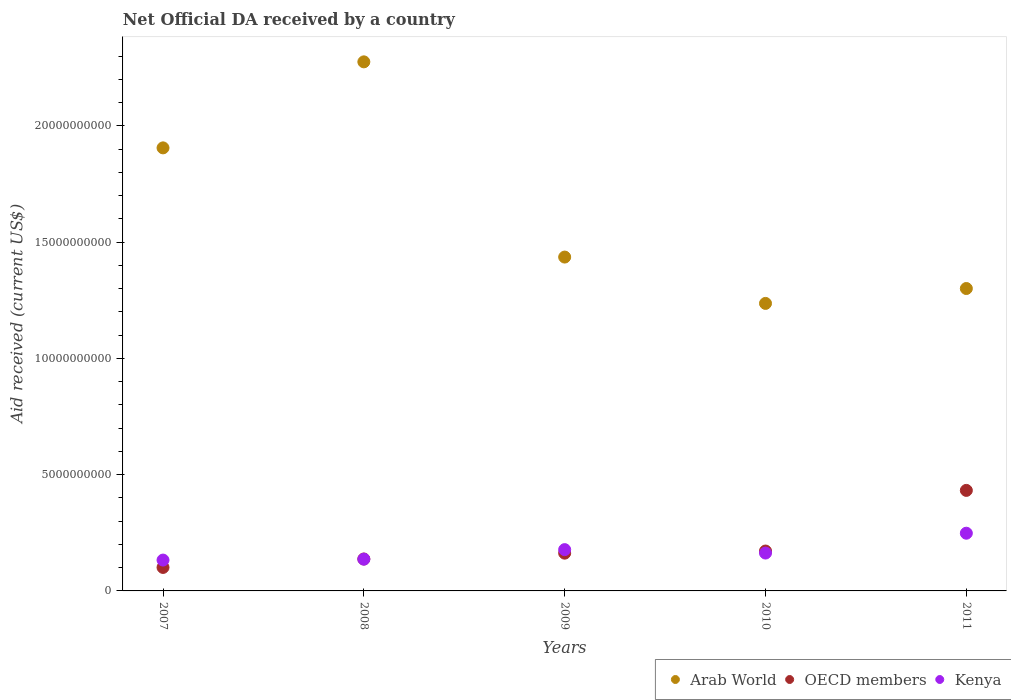How many different coloured dotlines are there?
Offer a very short reply. 3. What is the net official development assistance aid received in Kenya in 2007?
Offer a terse response. 1.33e+09. Across all years, what is the maximum net official development assistance aid received in Kenya?
Your answer should be compact. 2.48e+09. Across all years, what is the minimum net official development assistance aid received in OECD members?
Give a very brief answer. 1.01e+09. What is the total net official development assistance aid received in Kenya in the graph?
Provide a short and direct response. 8.58e+09. What is the difference between the net official development assistance aid received in Arab World in 2008 and that in 2009?
Offer a terse response. 8.40e+09. What is the difference between the net official development assistance aid received in Arab World in 2010 and the net official development assistance aid received in OECD members in 2008?
Provide a succinct answer. 1.10e+1. What is the average net official development assistance aid received in Arab World per year?
Your answer should be compact. 1.63e+1. In the year 2007, what is the difference between the net official development assistance aid received in OECD members and net official development assistance aid received in Arab World?
Keep it short and to the point. -1.80e+1. In how many years, is the net official development assistance aid received in Arab World greater than 21000000000 US$?
Ensure brevity in your answer.  1. What is the ratio of the net official development assistance aid received in Arab World in 2007 to that in 2009?
Your answer should be compact. 1.33. Is the difference between the net official development assistance aid received in OECD members in 2007 and 2009 greater than the difference between the net official development assistance aid received in Arab World in 2007 and 2009?
Give a very brief answer. No. What is the difference between the highest and the second highest net official development assistance aid received in Arab World?
Offer a terse response. 3.70e+09. What is the difference between the highest and the lowest net official development assistance aid received in OECD members?
Your answer should be compact. 3.31e+09. Is the sum of the net official development assistance aid received in OECD members in 2010 and 2011 greater than the maximum net official development assistance aid received in Kenya across all years?
Offer a very short reply. Yes. Is it the case that in every year, the sum of the net official development assistance aid received in Arab World and net official development assistance aid received in Kenya  is greater than the net official development assistance aid received in OECD members?
Your answer should be compact. Yes. Does the net official development assistance aid received in Kenya monotonically increase over the years?
Provide a succinct answer. No. Is the net official development assistance aid received in Kenya strictly greater than the net official development assistance aid received in OECD members over the years?
Offer a very short reply. No. Is the net official development assistance aid received in Kenya strictly less than the net official development assistance aid received in OECD members over the years?
Give a very brief answer. No. What is the difference between two consecutive major ticks on the Y-axis?
Your answer should be compact. 5.00e+09. Are the values on the major ticks of Y-axis written in scientific E-notation?
Provide a short and direct response. No. Does the graph contain any zero values?
Provide a short and direct response. No. What is the title of the graph?
Your answer should be very brief. Net Official DA received by a country. What is the label or title of the X-axis?
Your response must be concise. Years. What is the label or title of the Y-axis?
Your answer should be compact. Aid received (current US$). What is the Aid received (current US$) in Arab World in 2007?
Provide a succinct answer. 1.91e+1. What is the Aid received (current US$) of OECD members in 2007?
Your answer should be very brief. 1.01e+09. What is the Aid received (current US$) in Kenya in 2007?
Give a very brief answer. 1.33e+09. What is the Aid received (current US$) in Arab World in 2008?
Your response must be concise. 2.28e+1. What is the Aid received (current US$) of OECD members in 2008?
Your answer should be very brief. 1.37e+09. What is the Aid received (current US$) in Kenya in 2008?
Provide a succinct answer. 1.37e+09. What is the Aid received (current US$) in Arab World in 2009?
Keep it short and to the point. 1.44e+1. What is the Aid received (current US$) in OECD members in 2009?
Ensure brevity in your answer.  1.62e+09. What is the Aid received (current US$) of Kenya in 2009?
Make the answer very short. 1.78e+09. What is the Aid received (current US$) of Arab World in 2010?
Your answer should be compact. 1.24e+1. What is the Aid received (current US$) in OECD members in 2010?
Provide a short and direct response. 1.72e+09. What is the Aid received (current US$) of Kenya in 2010?
Offer a terse response. 1.63e+09. What is the Aid received (current US$) in Arab World in 2011?
Provide a short and direct response. 1.30e+1. What is the Aid received (current US$) of OECD members in 2011?
Make the answer very short. 4.32e+09. What is the Aid received (current US$) of Kenya in 2011?
Provide a short and direct response. 2.48e+09. Across all years, what is the maximum Aid received (current US$) of Arab World?
Keep it short and to the point. 2.28e+1. Across all years, what is the maximum Aid received (current US$) in OECD members?
Offer a very short reply. 4.32e+09. Across all years, what is the maximum Aid received (current US$) of Kenya?
Make the answer very short. 2.48e+09. Across all years, what is the minimum Aid received (current US$) in Arab World?
Give a very brief answer. 1.24e+1. Across all years, what is the minimum Aid received (current US$) of OECD members?
Keep it short and to the point. 1.01e+09. Across all years, what is the minimum Aid received (current US$) of Kenya?
Your answer should be very brief. 1.33e+09. What is the total Aid received (current US$) of Arab World in the graph?
Your response must be concise. 8.16e+1. What is the total Aid received (current US$) of OECD members in the graph?
Ensure brevity in your answer.  1.00e+1. What is the total Aid received (current US$) of Kenya in the graph?
Provide a short and direct response. 8.58e+09. What is the difference between the Aid received (current US$) of Arab World in 2007 and that in 2008?
Your answer should be very brief. -3.70e+09. What is the difference between the Aid received (current US$) in OECD members in 2007 and that in 2008?
Provide a short and direct response. -3.63e+08. What is the difference between the Aid received (current US$) of Kenya in 2007 and that in 2008?
Your response must be concise. -3.92e+07. What is the difference between the Aid received (current US$) in Arab World in 2007 and that in 2009?
Ensure brevity in your answer.  4.70e+09. What is the difference between the Aid received (current US$) in OECD members in 2007 and that in 2009?
Provide a succinct answer. -6.14e+08. What is the difference between the Aid received (current US$) in Kenya in 2007 and that in 2009?
Your answer should be compact. -4.49e+08. What is the difference between the Aid received (current US$) in Arab World in 2007 and that in 2010?
Provide a succinct answer. 6.69e+09. What is the difference between the Aid received (current US$) of OECD members in 2007 and that in 2010?
Ensure brevity in your answer.  -7.05e+08. What is the difference between the Aid received (current US$) of Kenya in 2007 and that in 2010?
Offer a very short reply. -3.02e+08. What is the difference between the Aid received (current US$) in Arab World in 2007 and that in 2011?
Provide a succinct answer. 6.05e+09. What is the difference between the Aid received (current US$) in OECD members in 2007 and that in 2011?
Your answer should be very brief. -3.31e+09. What is the difference between the Aid received (current US$) in Kenya in 2007 and that in 2011?
Offer a very short reply. -1.16e+09. What is the difference between the Aid received (current US$) in Arab World in 2008 and that in 2009?
Offer a terse response. 8.40e+09. What is the difference between the Aid received (current US$) in OECD members in 2008 and that in 2009?
Offer a very short reply. -2.52e+08. What is the difference between the Aid received (current US$) in Kenya in 2008 and that in 2009?
Make the answer very short. -4.10e+08. What is the difference between the Aid received (current US$) of Arab World in 2008 and that in 2010?
Offer a very short reply. 1.04e+1. What is the difference between the Aid received (current US$) in OECD members in 2008 and that in 2010?
Your response must be concise. -3.43e+08. What is the difference between the Aid received (current US$) of Kenya in 2008 and that in 2010?
Make the answer very short. -2.63e+08. What is the difference between the Aid received (current US$) in Arab World in 2008 and that in 2011?
Keep it short and to the point. 9.75e+09. What is the difference between the Aid received (current US$) in OECD members in 2008 and that in 2011?
Provide a short and direct response. -2.95e+09. What is the difference between the Aid received (current US$) of Kenya in 2008 and that in 2011?
Provide a short and direct response. -1.12e+09. What is the difference between the Aid received (current US$) in Arab World in 2009 and that in 2010?
Ensure brevity in your answer.  1.99e+09. What is the difference between the Aid received (current US$) of OECD members in 2009 and that in 2010?
Offer a very short reply. -9.10e+07. What is the difference between the Aid received (current US$) in Kenya in 2009 and that in 2010?
Make the answer very short. 1.48e+08. What is the difference between the Aid received (current US$) in Arab World in 2009 and that in 2011?
Make the answer very short. 1.35e+09. What is the difference between the Aid received (current US$) of OECD members in 2009 and that in 2011?
Give a very brief answer. -2.70e+09. What is the difference between the Aid received (current US$) in Kenya in 2009 and that in 2011?
Make the answer very short. -7.06e+08. What is the difference between the Aid received (current US$) of Arab World in 2010 and that in 2011?
Your answer should be very brief. -6.41e+08. What is the difference between the Aid received (current US$) in OECD members in 2010 and that in 2011?
Ensure brevity in your answer.  -2.61e+09. What is the difference between the Aid received (current US$) of Kenya in 2010 and that in 2011?
Provide a succinct answer. -8.54e+08. What is the difference between the Aid received (current US$) in Arab World in 2007 and the Aid received (current US$) in OECD members in 2008?
Your answer should be very brief. 1.77e+1. What is the difference between the Aid received (current US$) in Arab World in 2007 and the Aid received (current US$) in Kenya in 2008?
Make the answer very short. 1.77e+1. What is the difference between the Aid received (current US$) in OECD members in 2007 and the Aid received (current US$) in Kenya in 2008?
Offer a very short reply. -3.56e+08. What is the difference between the Aid received (current US$) in Arab World in 2007 and the Aid received (current US$) in OECD members in 2009?
Your answer should be very brief. 1.74e+1. What is the difference between the Aid received (current US$) of Arab World in 2007 and the Aid received (current US$) of Kenya in 2009?
Provide a short and direct response. 1.73e+1. What is the difference between the Aid received (current US$) in OECD members in 2007 and the Aid received (current US$) in Kenya in 2009?
Give a very brief answer. -7.66e+08. What is the difference between the Aid received (current US$) in Arab World in 2007 and the Aid received (current US$) in OECD members in 2010?
Give a very brief answer. 1.73e+1. What is the difference between the Aid received (current US$) in Arab World in 2007 and the Aid received (current US$) in Kenya in 2010?
Ensure brevity in your answer.  1.74e+1. What is the difference between the Aid received (current US$) of OECD members in 2007 and the Aid received (current US$) of Kenya in 2010?
Provide a succinct answer. -6.18e+08. What is the difference between the Aid received (current US$) in Arab World in 2007 and the Aid received (current US$) in OECD members in 2011?
Offer a terse response. 1.47e+1. What is the difference between the Aid received (current US$) of Arab World in 2007 and the Aid received (current US$) of Kenya in 2011?
Your answer should be very brief. 1.66e+1. What is the difference between the Aid received (current US$) of OECD members in 2007 and the Aid received (current US$) of Kenya in 2011?
Offer a terse response. -1.47e+09. What is the difference between the Aid received (current US$) in Arab World in 2008 and the Aid received (current US$) in OECD members in 2009?
Your response must be concise. 2.11e+1. What is the difference between the Aid received (current US$) in Arab World in 2008 and the Aid received (current US$) in Kenya in 2009?
Your response must be concise. 2.10e+1. What is the difference between the Aid received (current US$) of OECD members in 2008 and the Aid received (current US$) of Kenya in 2009?
Keep it short and to the point. -4.03e+08. What is the difference between the Aid received (current US$) of Arab World in 2008 and the Aid received (current US$) of OECD members in 2010?
Your answer should be very brief. 2.10e+1. What is the difference between the Aid received (current US$) in Arab World in 2008 and the Aid received (current US$) in Kenya in 2010?
Provide a succinct answer. 2.11e+1. What is the difference between the Aid received (current US$) of OECD members in 2008 and the Aid received (current US$) of Kenya in 2010?
Make the answer very short. -2.55e+08. What is the difference between the Aid received (current US$) in Arab World in 2008 and the Aid received (current US$) in OECD members in 2011?
Offer a very short reply. 1.84e+1. What is the difference between the Aid received (current US$) in Arab World in 2008 and the Aid received (current US$) in Kenya in 2011?
Give a very brief answer. 2.03e+1. What is the difference between the Aid received (current US$) of OECD members in 2008 and the Aid received (current US$) of Kenya in 2011?
Make the answer very short. -1.11e+09. What is the difference between the Aid received (current US$) in Arab World in 2009 and the Aid received (current US$) in OECD members in 2010?
Offer a very short reply. 1.26e+1. What is the difference between the Aid received (current US$) of Arab World in 2009 and the Aid received (current US$) of Kenya in 2010?
Provide a short and direct response. 1.27e+1. What is the difference between the Aid received (current US$) of OECD members in 2009 and the Aid received (current US$) of Kenya in 2010?
Your response must be concise. -3.87e+06. What is the difference between the Aid received (current US$) in Arab World in 2009 and the Aid received (current US$) in OECD members in 2011?
Ensure brevity in your answer.  1.00e+1. What is the difference between the Aid received (current US$) in Arab World in 2009 and the Aid received (current US$) in Kenya in 2011?
Your response must be concise. 1.19e+1. What is the difference between the Aid received (current US$) in OECD members in 2009 and the Aid received (current US$) in Kenya in 2011?
Ensure brevity in your answer.  -8.58e+08. What is the difference between the Aid received (current US$) in Arab World in 2010 and the Aid received (current US$) in OECD members in 2011?
Provide a short and direct response. 8.04e+09. What is the difference between the Aid received (current US$) of Arab World in 2010 and the Aid received (current US$) of Kenya in 2011?
Provide a succinct answer. 9.88e+09. What is the difference between the Aid received (current US$) in OECD members in 2010 and the Aid received (current US$) in Kenya in 2011?
Provide a succinct answer. -7.67e+08. What is the average Aid received (current US$) in Arab World per year?
Provide a succinct answer. 1.63e+1. What is the average Aid received (current US$) of OECD members per year?
Give a very brief answer. 2.01e+09. What is the average Aid received (current US$) in Kenya per year?
Offer a terse response. 1.72e+09. In the year 2007, what is the difference between the Aid received (current US$) in Arab World and Aid received (current US$) in OECD members?
Keep it short and to the point. 1.80e+1. In the year 2007, what is the difference between the Aid received (current US$) of Arab World and Aid received (current US$) of Kenya?
Ensure brevity in your answer.  1.77e+1. In the year 2007, what is the difference between the Aid received (current US$) of OECD members and Aid received (current US$) of Kenya?
Ensure brevity in your answer.  -3.16e+08. In the year 2008, what is the difference between the Aid received (current US$) of Arab World and Aid received (current US$) of OECD members?
Provide a short and direct response. 2.14e+1. In the year 2008, what is the difference between the Aid received (current US$) in Arab World and Aid received (current US$) in Kenya?
Offer a terse response. 2.14e+1. In the year 2008, what is the difference between the Aid received (current US$) in OECD members and Aid received (current US$) in Kenya?
Offer a very short reply. 7.17e+06. In the year 2009, what is the difference between the Aid received (current US$) in Arab World and Aid received (current US$) in OECD members?
Ensure brevity in your answer.  1.27e+1. In the year 2009, what is the difference between the Aid received (current US$) of Arab World and Aid received (current US$) of Kenya?
Your response must be concise. 1.26e+1. In the year 2009, what is the difference between the Aid received (current US$) in OECD members and Aid received (current US$) in Kenya?
Ensure brevity in your answer.  -1.52e+08. In the year 2010, what is the difference between the Aid received (current US$) in Arab World and Aid received (current US$) in OECD members?
Your response must be concise. 1.07e+1. In the year 2010, what is the difference between the Aid received (current US$) of Arab World and Aid received (current US$) of Kenya?
Your answer should be compact. 1.07e+1. In the year 2010, what is the difference between the Aid received (current US$) of OECD members and Aid received (current US$) of Kenya?
Ensure brevity in your answer.  8.72e+07. In the year 2011, what is the difference between the Aid received (current US$) of Arab World and Aid received (current US$) of OECD members?
Offer a very short reply. 8.68e+09. In the year 2011, what is the difference between the Aid received (current US$) in Arab World and Aid received (current US$) in Kenya?
Your answer should be very brief. 1.05e+1. In the year 2011, what is the difference between the Aid received (current US$) in OECD members and Aid received (current US$) in Kenya?
Offer a very short reply. 1.84e+09. What is the ratio of the Aid received (current US$) in Arab World in 2007 to that in 2008?
Offer a terse response. 0.84. What is the ratio of the Aid received (current US$) in OECD members in 2007 to that in 2008?
Make the answer very short. 0.74. What is the ratio of the Aid received (current US$) in Kenya in 2007 to that in 2008?
Keep it short and to the point. 0.97. What is the ratio of the Aid received (current US$) in Arab World in 2007 to that in 2009?
Provide a succinct answer. 1.33. What is the ratio of the Aid received (current US$) in OECD members in 2007 to that in 2009?
Provide a short and direct response. 0.62. What is the ratio of the Aid received (current US$) of Kenya in 2007 to that in 2009?
Ensure brevity in your answer.  0.75. What is the ratio of the Aid received (current US$) of Arab World in 2007 to that in 2010?
Provide a succinct answer. 1.54. What is the ratio of the Aid received (current US$) of OECD members in 2007 to that in 2010?
Your answer should be very brief. 0.59. What is the ratio of the Aid received (current US$) of Kenya in 2007 to that in 2010?
Ensure brevity in your answer.  0.81. What is the ratio of the Aid received (current US$) in Arab World in 2007 to that in 2011?
Ensure brevity in your answer.  1.47. What is the ratio of the Aid received (current US$) of OECD members in 2007 to that in 2011?
Your answer should be compact. 0.23. What is the ratio of the Aid received (current US$) in Kenya in 2007 to that in 2011?
Ensure brevity in your answer.  0.53. What is the ratio of the Aid received (current US$) of Arab World in 2008 to that in 2009?
Provide a short and direct response. 1.58. What is the ratio of the Aid received (current US$) in OECD members in 2008 to that in 2009?
Offer a very short reply. 0.85. What is the ratio of the Aid received (current US$) in Kenya in 2008 to that in 2009?
Provide a succinct answer. 0.77. What is the ratio of the Aid received (current US$) of Arab World in 2008 to that in 2010?
Offer a terse response. 1.84. What is the ratio of the Aid received (current US$) of OECD members in 2008 to that in 2010?
Keep it short and to the point. 0.8. What is the ratio of the Aid received (current US$) in Kenya in 2008 to that in 2010?
Make the answer very short. 0.84. What is the ratio of the Aid received (current US$) in Arab World in 2008 to that in 2011?
Provide a short and direct response. 1.75. What is the ratio of the Aid received (current US$) of OECD members in 2008 to that in 2011?
Your answer should be very brief. 0.32. What is the ratio of the Aid received (current US$) of Kenya in 2008 to that in 2011?
Keep it short and to the point. 0.55. What is the ratio of the Aid received (current US$) of Arab World in 2009 to that in 2010?
Make the answer very short. 1.16. What is the ratio of the Aid received (current US$) in OECD members in 2009 to that in 2010?
Your answer should be very brief. 0.95. What is the ratio of the Aid received (current US$) in Kenya in 2009 to that in 2010?
Keep it short and to the point. 1.09. What is the ratio of the Aid received (current US$) in Arab World in 2009 to that in 2011?
Your answer should be compact. 1.1. What is the ratio of the Aid received (current US$) in OECD members in 2009 to that in 2011?
Your response must be concise. 0.38. What is the ratio of the Aid received (current US$) in Kenya in 2009 to that in 2011?
Provide a succinct answer. 0.72. What is the ratio of the Aid received (current US$) of Arab World in 2010 to that in 2011?
Provide a succinct answer. 0.95. What is the ratio of the Aid received (current US$) of OECD members in 2010 to that in 2011?
Ensure brevity in your answer.  0.4. What is the ratio of the Aid received (current US$) of Kenya in 2010 to that in 2011?
Provide a succinct answer. 0.66. What is the difference between the highest and the second highest Aid received (current US$) in Arab World?
Ensure brevity in your answer.  3.70e+09. What is the difference between the highest and the second highest Aid received (current US$) in OECD members?
Make the answer very short. 2.61e+09. What is the difference between the highest and the second highest Aid received (current US$) of Kenya?
Offer a terse response. 7.06e+08. What is the difference between the highest and the lowest Aid received (current US$) of Arab World?
Your response must be concise. 1.04e+1. What is the difference between the highest and the lowest Aid received (current US$) in OECD members?
Provide a succinct answer. 3.31e+09. What is the difference between the highest and the lowest Aid received (current US$) in Kenya?
Provide a short and direct response. 1.16e+09. 